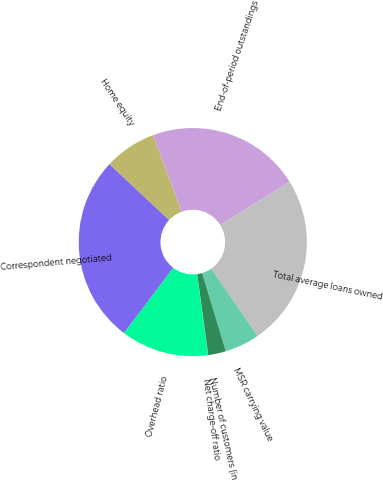Convert chart to OTSL. <chart><loc_0><loc_0><loc_500><loc_500><pie_chart><fcel>Correspondent negotiated<fcel>Home equity<fcel>End-of-period outstandings<fcel>Total average loans owned<fcel>MSR carrying value<fcel>Number of customers (in<fcel>Net charge-off ratio<fcel>Overhead ratio<nl><fcel>26.68%<fcel>7.39%<fcel>21.78%<fcel>24.23%<fcel>4.95%<fcel>2.5%<fcel>0.05%<fcel>12.41%<nl></chart> 